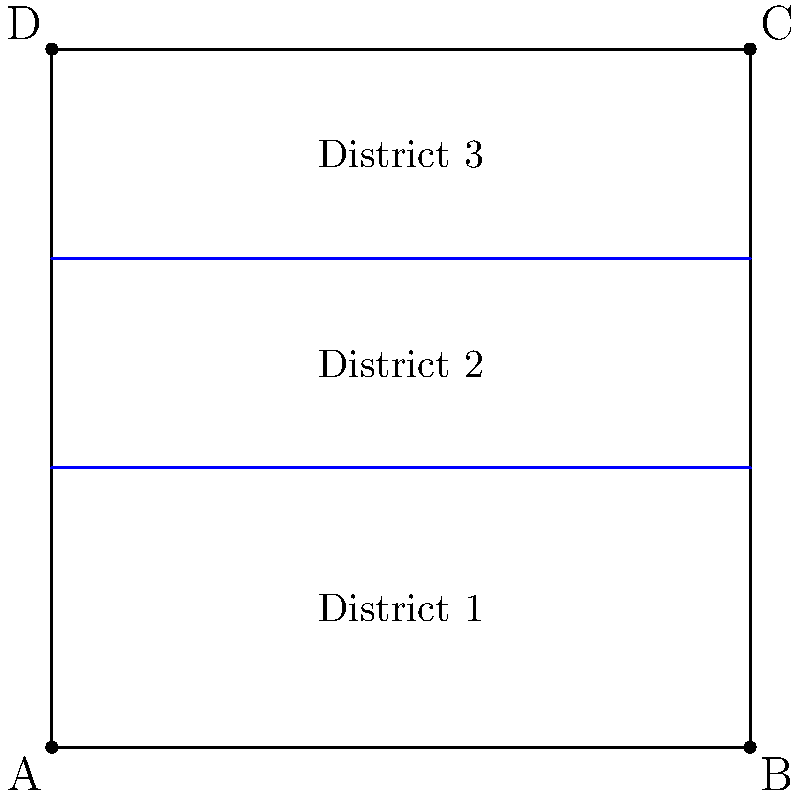In the diagram above, a square state is divided into three voting districts by two parallel lines. If the total population of the state is 900,000 and the population density is uniform, what is the population of District 2? Given that political corruption often leads to unfair districting, how might this division affect voter representation? Let's approach this step-by-step:

1) First, we need to calculate the area of each district relative to the whole square.

2) The square is divided into three parts. Let's call the height of the square $h$.
   - District 1: from 0 to $0.4h$
   - District 2: from $0.4h$ to $0.7h$
   - District 3: from $0.7h$ to $h$

3) The area of each district is proportional to its height:
   - District 1: $0.4h/h = 0.4$ or 40% of the total area
   - District 2: $(0.7h - 0.4h)/h = 0.3$ or 30% of the total area
   - District 3: $(h - 0.7h)/h = 0.3$ or 30% of the total area

4) Given that the population density is uniform, the population of each district is proportional to its area.

5) The total population is 900,000, so:
   - District 2 population = 30% of 900,000 = 0.3 * 900,000 = 270,000

Regarding voter representation:
This division creates three unequal districts, with District 1 having a larger population than Districts 2 and 3. In a corrupt system, this could be used to concentrate opposition voters in one district (gerrymandering), diluting their voting power in the other two districts. This unfair practice undermines the principle of equal representation and can lead to election outcomes that don't accurately reflect the will of the majority.
Answer: 270,000 